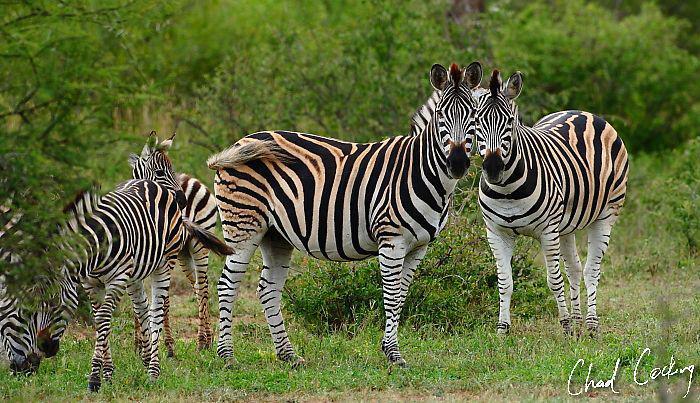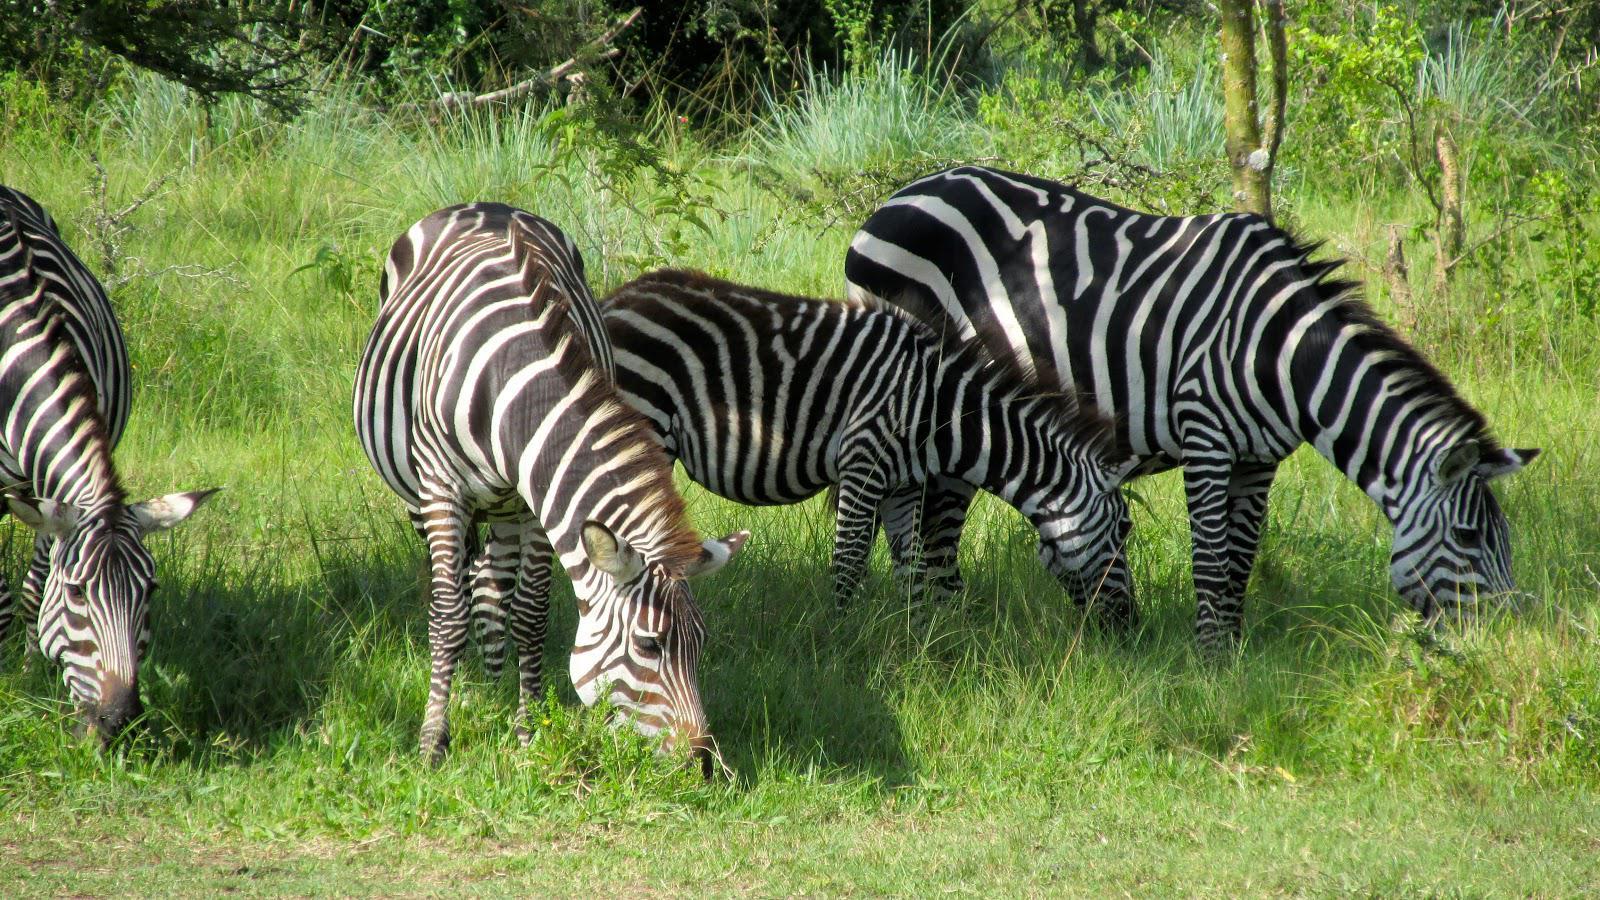The first image is the image on the left, the second image is the image on the right. Given the left and right images, does the statement "In the foreground of the lefthand image, two zebras stand with bodies turned toward each other and faces turned to the camera." hold true? Answer yes or no. Yes. The first image is the image on the left, the second image is the image on the right. Evaluate the accuracy of this statement regarding the images: "No more than one zebra has its head down in the image on the right.". Is it true? Answer yes or no. No. 